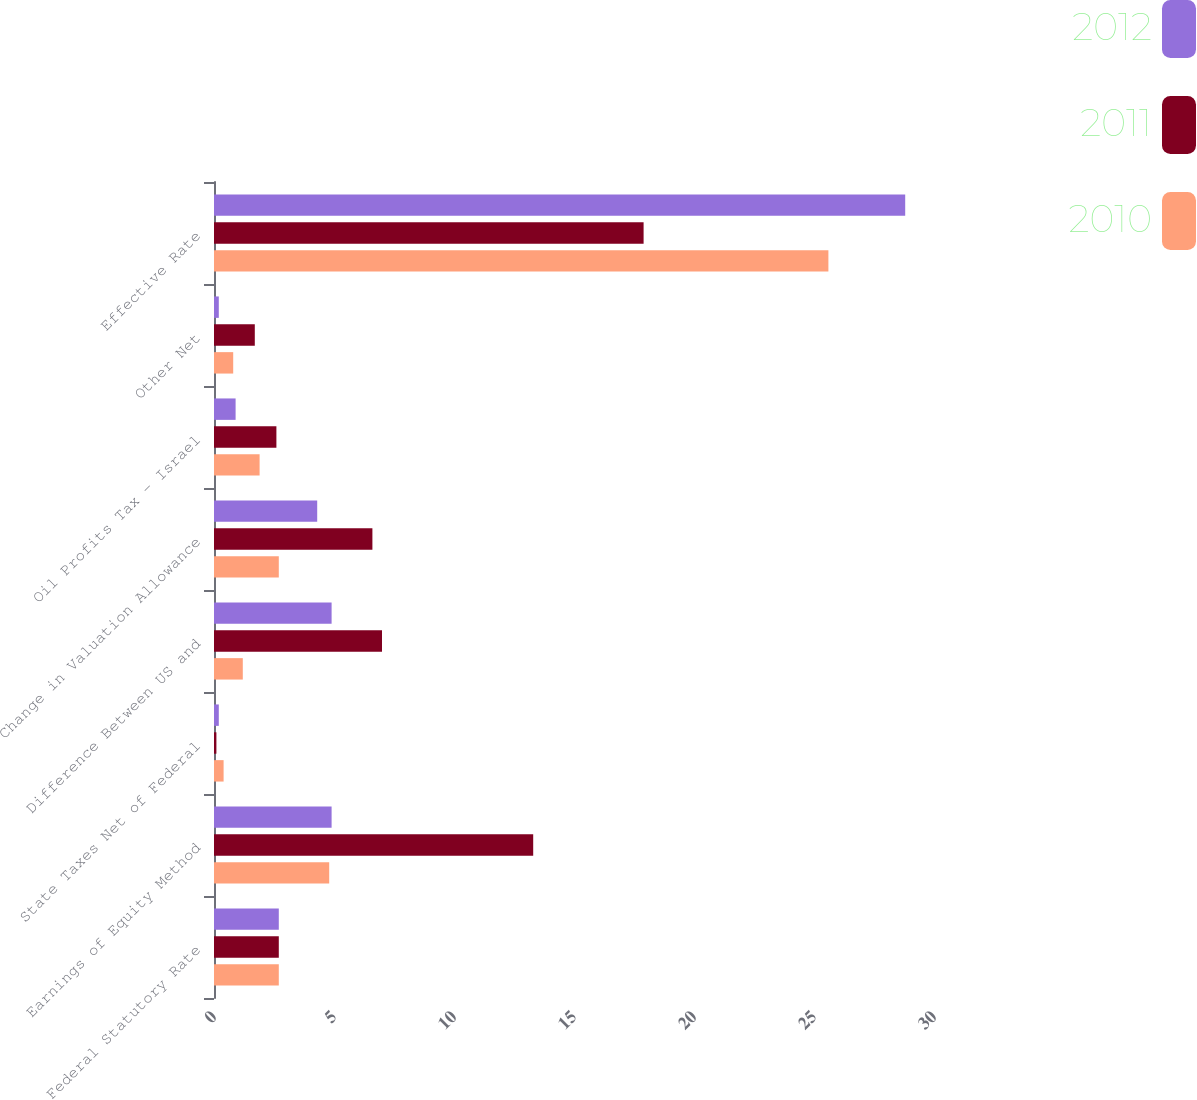Convert chart. <chart><loc_0><loc_0><loc_500><loc_500><stacked_bar_chart><ecel><fcel>Federal Statutory Rate<fcel>Earnings of Equity Method<fcel>State Taxes Net of Federal<fcel>Difference Between US and<fcel>Change in Valuation Allowance<fcel>Oil Profits Tax - Israel<fcel>Other Net<fcel>Effective Rate<nl><fcel>2012<fcel>2.7<fcel>4.9<fcel>0.2<fcel>4.9<fcel>4.3<fcel>0.9<fcel>0.2<fcel>28.8<nl><fcel>2011<fcel>2.7<fcel>13.3<fcel>0.1<fcel>7<fcel>6.6<fcel>2.6<fcel>1.7<fcel>17.9<nl><fcel>2010<fcel>2.7<fcel>4.8<fcel>0.4<fcel>1.2<fcel>2.7<fcel>1.9<fcel>0.8<fcel>25.6<nl></chart> 